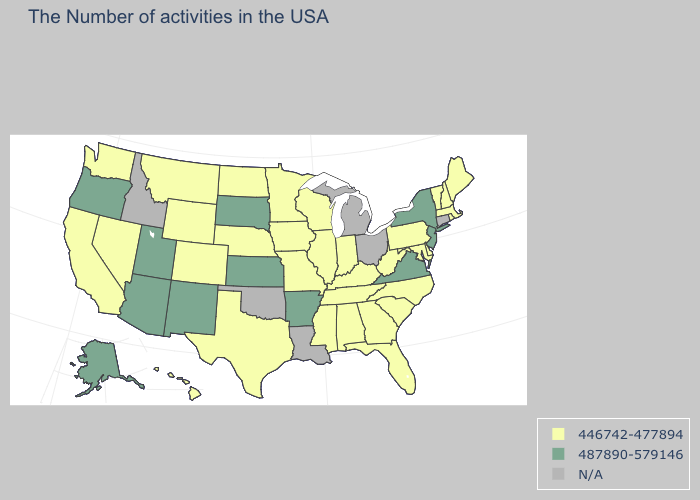What is the value of Nevada?
Keep it brief. 446742-477894. What is the lowest value in the USA?
Short answer required. 446742-477894. Which states have the highest value in the USA?
Be succinct. New York, New Jersey, Virginia, Arkansas, Kansas, South Dakota, New Mexico, Utah, Arizona, Oregon, Alaska. Which states have the lowest value in the USA?
Be succinct. Maine, Massachusetts, Rhode Island, New Hampshire, Vermont, Delaware, Maryland, Pennsylvania, North Carolina, South Carolina, West Virginia, Florida, Georgia, Kentucky, Indiana, Alabama, Tennessee, Wisconsin, Illinois, Mississippi, Missouri, Minnesota, Iowa, Nebraska, Texas, North Dakota, Wyoming, Colorado, Montana, Nevada, California, Washington, Hawaii. Name the states that have a value in the range 487890-579146?
Short answer required. New York, New Jersey, Virginia, Arkansas, Kansas, South Dakota, New Mexico, Utah, Arizona, Oregon, Alaska. Name the states that have a value in the range 487890-579146?
Be succinct. New York, New Jersey, Virginia, Arkansas, Kansas, South Dakota, New Mexico, Utah, Arizona, Oregon, Alaska. Which states have the highest value in the USA?
Answer briefly. New York, New Jersey, Virginia, Arkansas, Kansas, South Dakota, New Mexico, Utah, Arizona, Oregon, Alaska. Is the legend a continuous bar?
Give a very brief answer. No. Name the states that have a value in the range 487890-579146?
Concise answer only. New York, New Jersey, Virginia, Arkansas, Kansas, South Dakota, New Mexico, Utah, Arizona, Oregon, Alaska. Does the first symbol in the legend represent the smallest category?
Answer briefly. Yes. Which states have the lowest value in the South?
Concise answer only. Delaware, Maryland, North Carolina, South Carolina, West Virginia, Florida, Georgia, Kentucky, Alabama, Tennessee, Mississippi, Texas. What is the value of Kansas?
Answer briefly. 487890-579146. What is the value of Missouri?
Answer briefly. 446742-477894. Does Alaska have the highest value in the West?
Give a very brief answer. Yes. What is the value of Vermont?
Quick response, please. 446742-477894. 